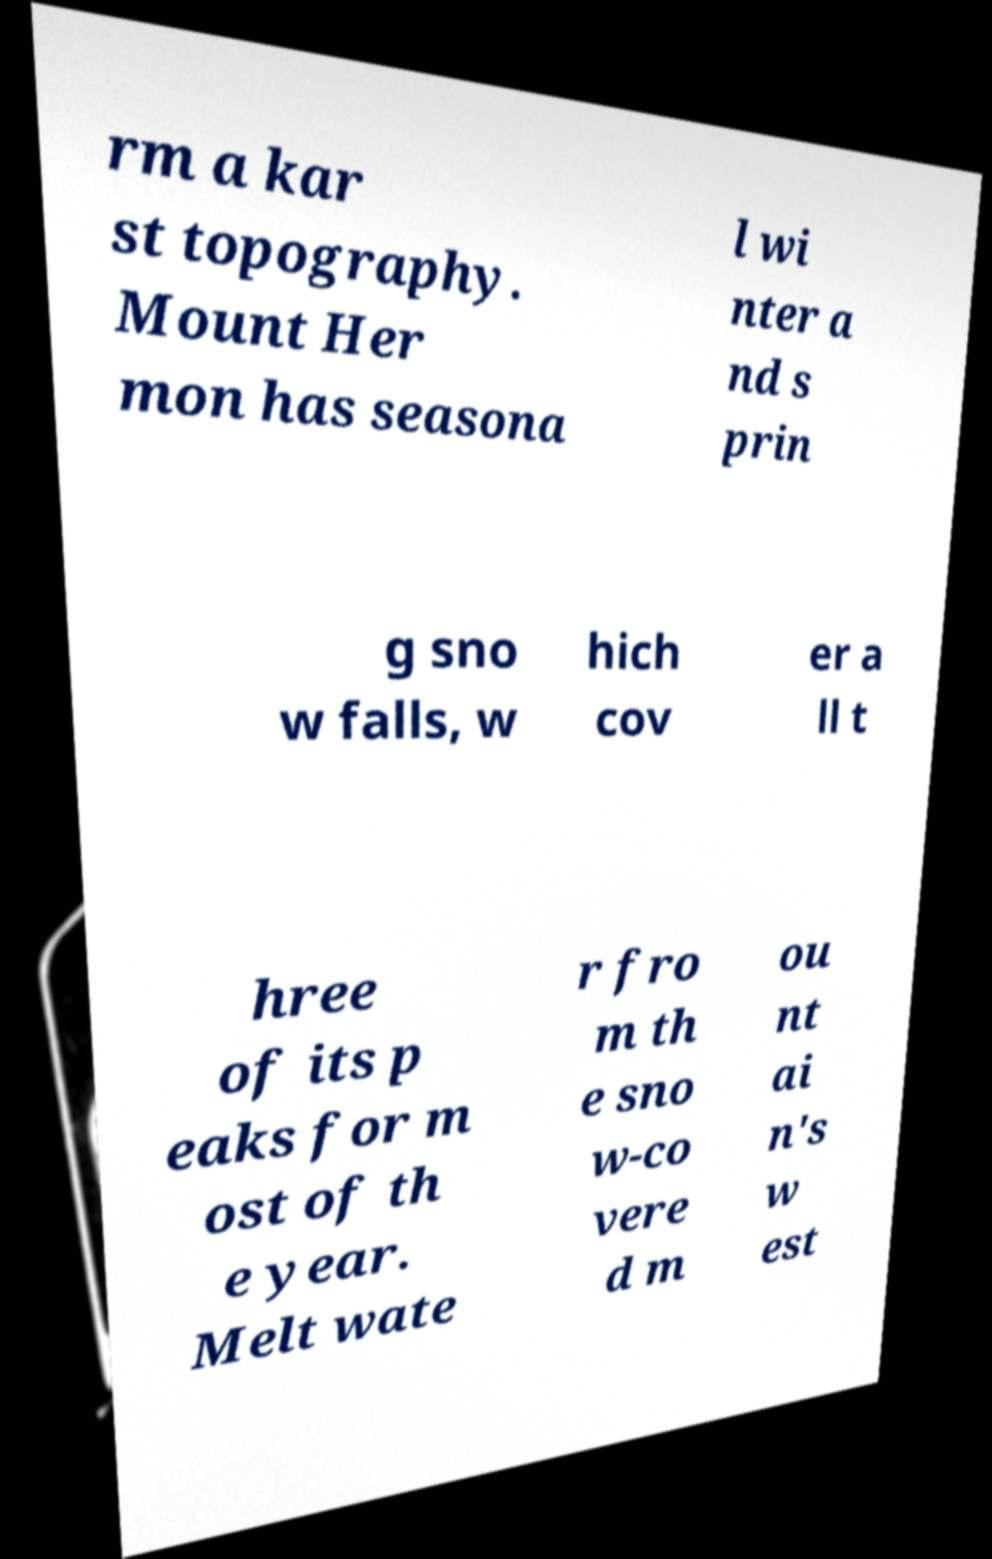For documentation purposes, I need the text within this image transcribed. Could you provide that? rm a kar st topography. Mount Her mon has seasona l wi nter a nd s prin g sno w falls, w hich cov er a ll t hree of its p eaks for m ost of th e year. Melt wate r fro m th e sno w-co vere d m ou nt ai n's w est 